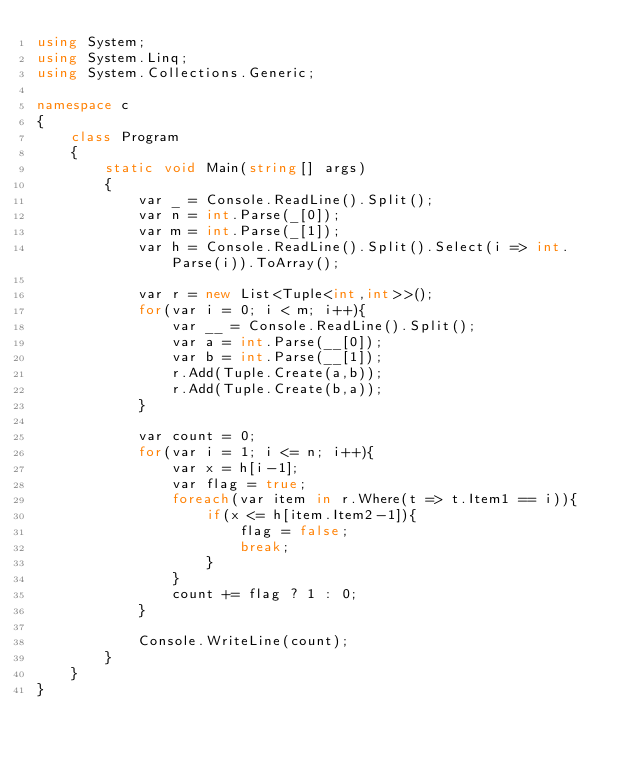<code> <loc_0><loc_0><loc_500><loc_500><_C#_>using System;
using System.Linq;
using System.Collections.Generic;

namespace c
{
    class Program
    {
        static void Main(string[] args)
        {
            var _ = Console.ReadLine().Split();
            var n = int.Parse(_[0]);
            var m = int.Parse(_[1]);
            var h = Console.ReadLine().Split().Select(i => int.Parse(i)).ToArray();

            var r = new List<Tuple<int,int>>();
            for(var i = 0; i < m; i++){
                var __ = Console.ReadLine().Split();
                var a = int.Parse(__[0]);
                var b = int.Parse(__[1]);
                r.Add(Tuple.Create(a,b));
                r.Add(Tuple.Create(b,a));
            }

            var count = 0;
            for(var i = 1; i <= n; i++){
                var x = h[i-1];
                var flag = true;
                foreach(var item in r.Where(t => t.Item1 == i)){
                    if(x <= h[item.Item2-1]){
                        flag = false;
                        break;
                    }
                }
                count += flag ? 1 : 0;
            }

            Console.WriteLine(count);
        }
    }
}
</code> 